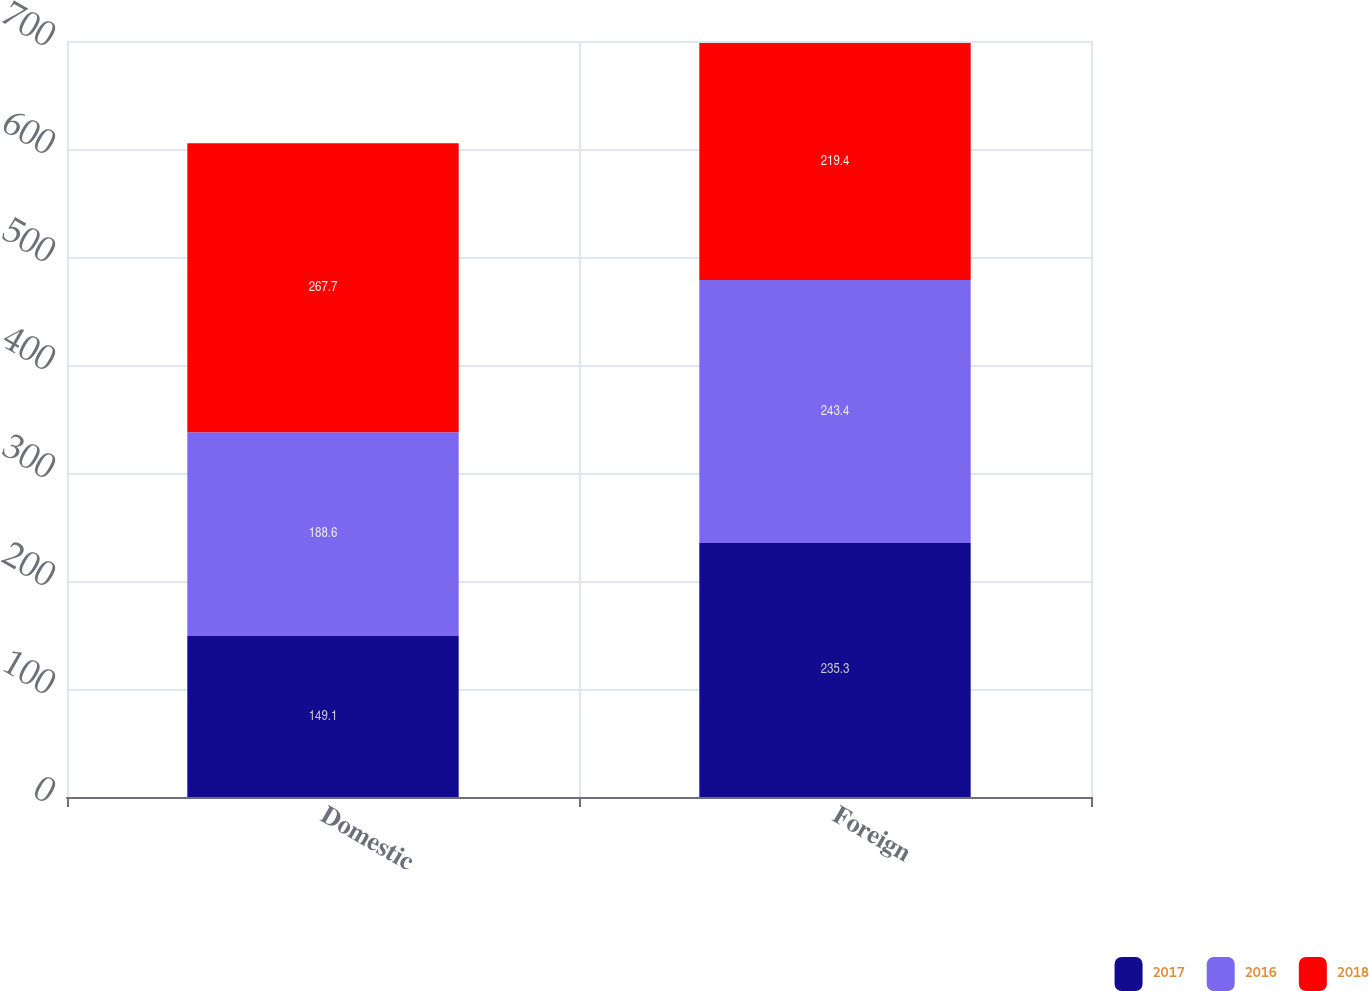<chart> <loc_0><loc_0><loc_500><loc_500><stacked_bar_chart><ecel><fcel>Domestic<fcel>Foreign<nl><fcel>2017<fcel>149.1<fcel>235.3<nl><fcel>2016<fcel>188.6<fcel>243.4<nl><fcel>2018<fcel>267.7<fcel>219.4<nl></chart> 